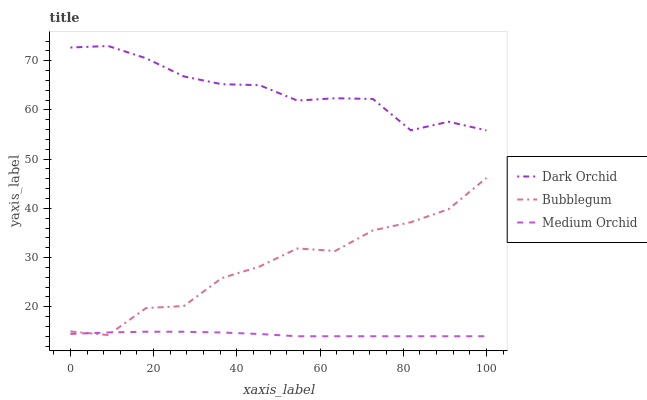Does Medium Orchid have the minimum area under the curve?
Answer yes or no. Yes. Does Dark Orchid have the maximum area under the curve?
Answer yes or no. Yes. Does Bubblegum have the minimum area under the curve?
Answer yes or no. No. Does Bubblegum have the maximum area under the curve?
Answer yes or no. No. Is Medium Orchid the smoothest?
Answer yes or no. Yes. Is Bubblegum the roughest?
Answer yes or no. Yes. Is Dark Orchid the smoothest?
Answer yes or no. No. Is Dark Orchid the roughest?
Answer yes or no. No. Does Bubblegum have the lowest value?
Answer yes or no. No. Does Dark Orchid have the highest value?
Answer yes or no. Yes. Does Bubblegum have the highest value?
Answer yes or no. No. Is Medium Orchid less than Dark Orchid?
Answer yes or no. Yes. Is Dark Orchid greater than Bubblegum?
Answer yes or no. Yes. Does Medium Orchid intersect Dark Orchid?
Answer yes or no. No. 